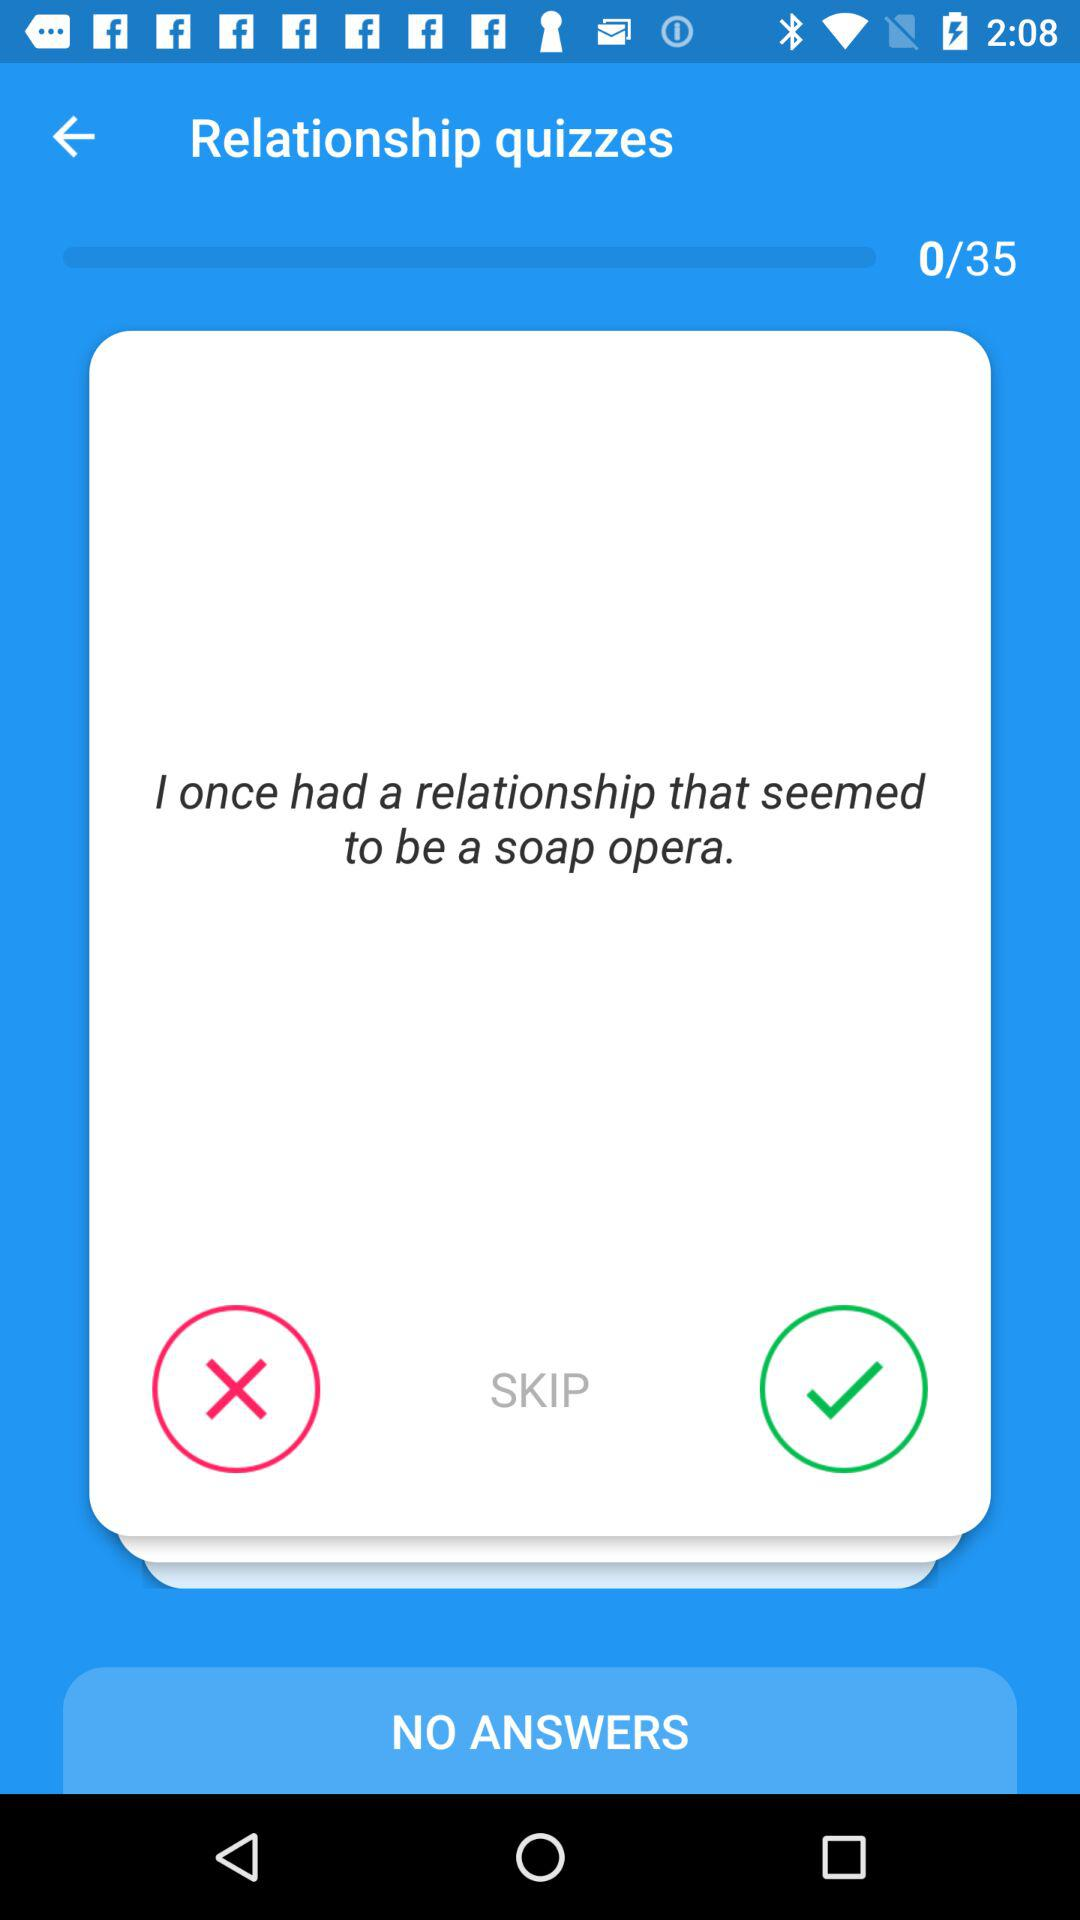What is the total number of quizzes? The total number of quizzes is 35. 